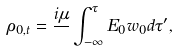Convert formula to latex. <formula><loc_0><loc_0><loc_500><loc_500>\rho _ { 0 , t } = \frac { i \mu } { } \int _ { - \infty } ^ { \tau } E _ { 0 } w _ { 0 } d \tau ^ { \prime } ,</formula> 